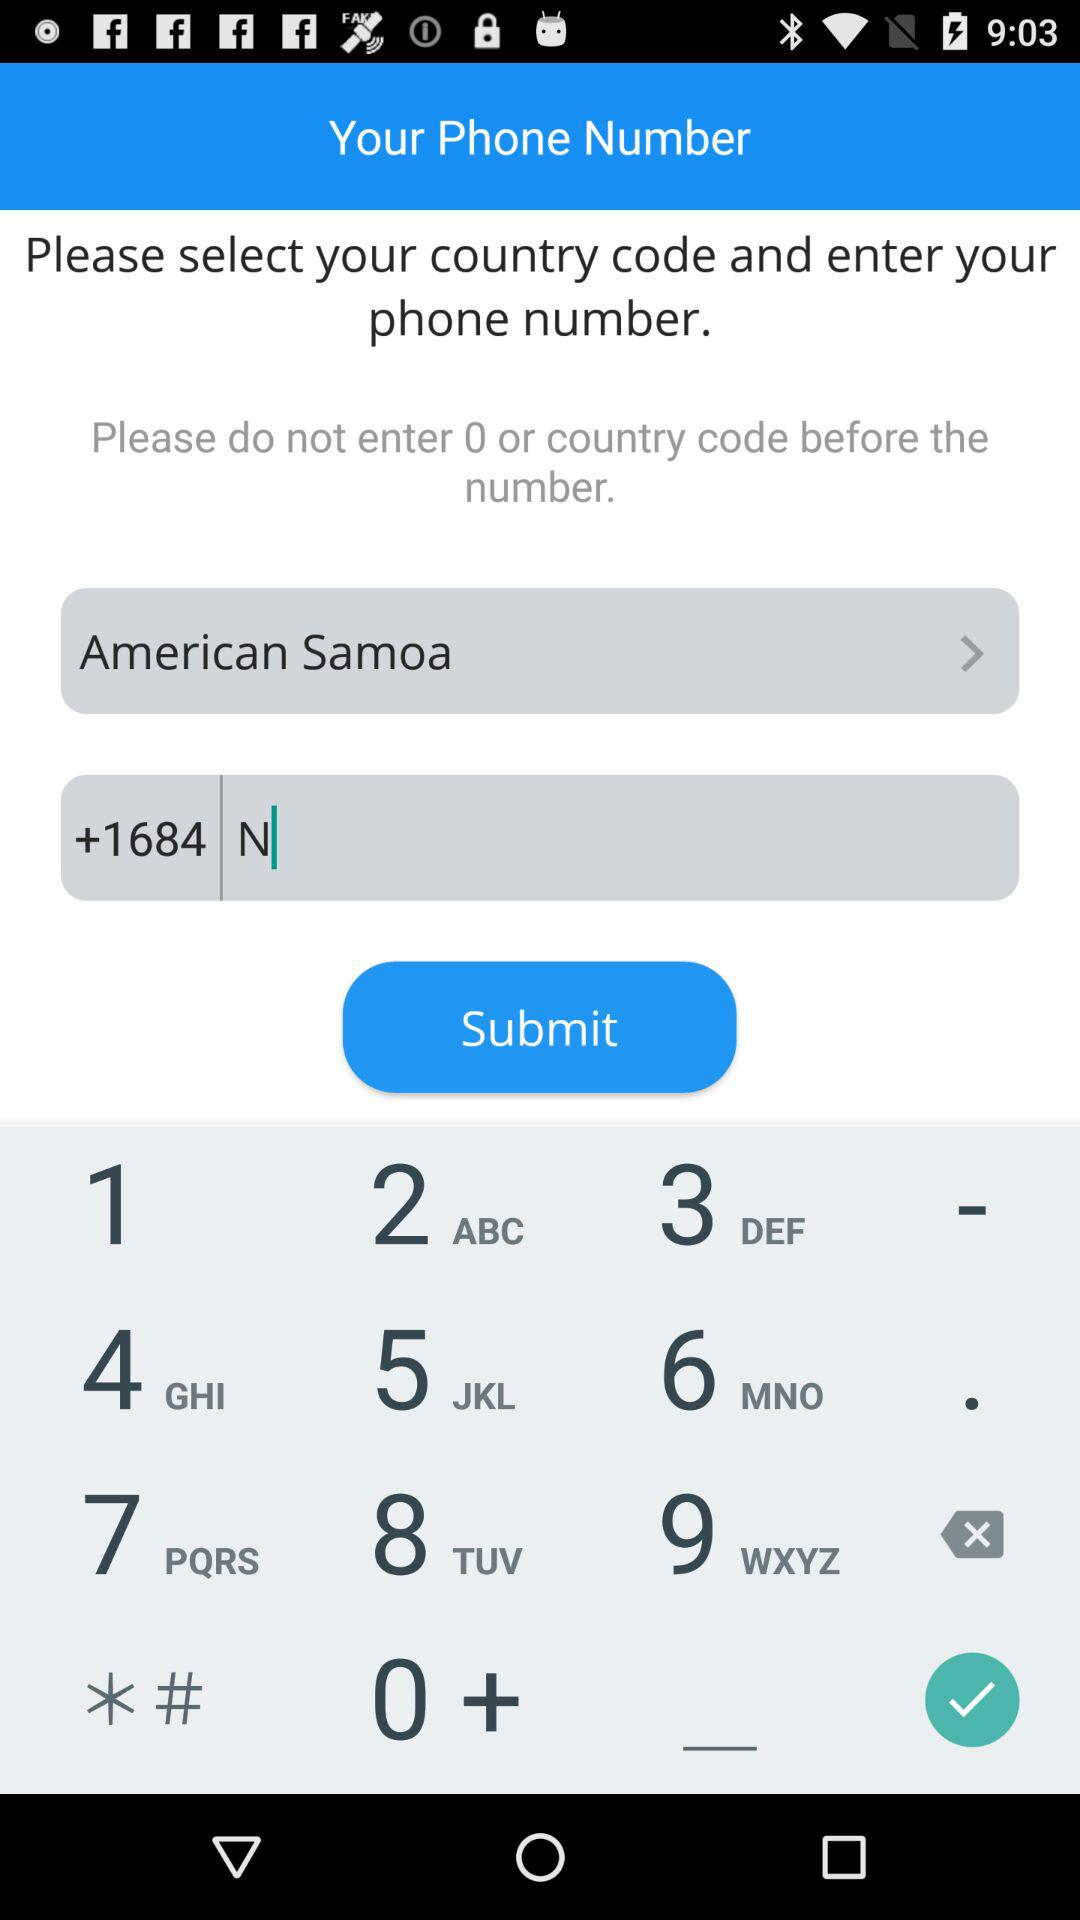What's the country code? The country code is +1684. 